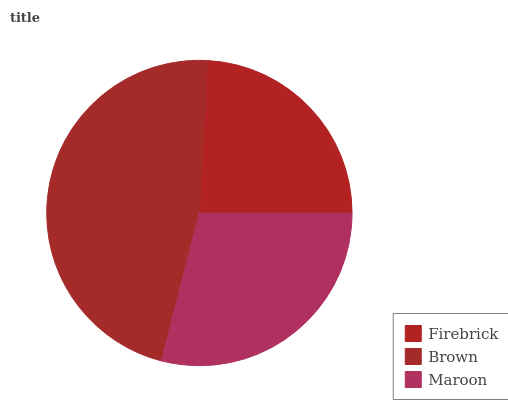Is Firebrick the minimum?
Answer yes or no. Yes. Is Brown the maximum?
Answer yes or no. Yes. Is Maroon the minimum?
Answer yes or no. No. Is Maroon the maximum?
Answer yes or no. No. Is Brown greater than Maroon?
Answer yes or no. Yes. Is Maroon less than Brown?
Answer yes or no. Yes. Is Maroon greater than Brown?
Answer yes or no. No. Is Brown less than Maroon?
Answer yes or no. No. Is Maroon the high median?
Answer yes or no. Yes. Is Maroon the low median?
Answer yes or no. Yes. Is Firebrick the high median?
Answer yes or no. No. Is Firebrick the low median?
Answer yes or no. No. 